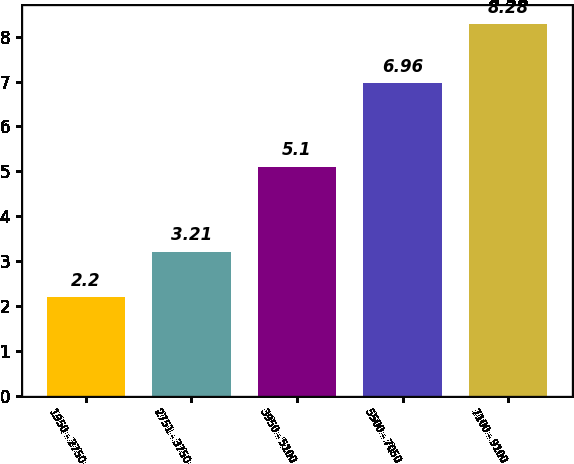<chart> <loc_0><loc_0><loc_500><loc_500><bar_chart><fcel>1950 - 2750<fcel>2751 - 3750<fcel>3950 - 5100<fcel>5500 - 7050<fcel>7100 - 9100<nl><fcel>2.2<fcel>3.21<fcel>5.1<fcel>6.96<fcel>8.28<nl></chart> 